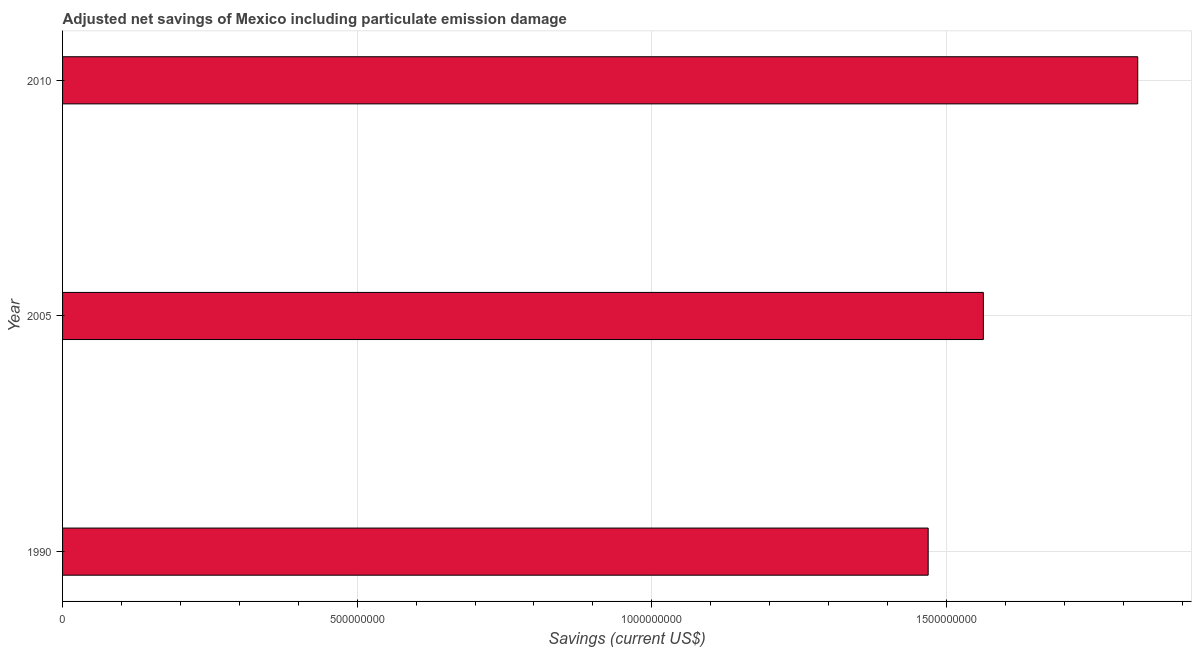Does the graph contain any zero values?
Give a very brief answer. No. Does the graph contain grids?
Ensure brevity in your answer.  Yes. What is the title of the graph?
Keep it short and to the point. Adjusted net savings of Mexico including particulate emission damage. What is the label or title of the X-axis?
Provide a succinct answer. Savings (current US$). What is the adjusted net savings in 2005?
Your response must be concise. 1.56e+09. Across all years, what is the maximum adjusted net savings?
Your answer should be very brief. 1.82e+09. Across all years, what is the minimum adjusted net savings?
Provide a short and direct response. 1.47e+09. What is the sum of the adjusted net savings?
Keep it short and to the point. 4.86e+09. What is the difference between the adjusted net savings in 1990 and 2010?
Provide a short and direct response. -3.56e+08. What is the average adjusted net savings per year?
Give a very brief answer. 1.62e+09. What is the median adjusted net savings?
Offer a very short reply. 1.56e+09. In how many years, is the adjusted net savings greater than 500000000 US$?
Make the answer very short. 3. Do a majority of the years between 1990 and 2005 (inclusive) have adjusted net savings greater than 1500000000 US$?
Make the answer very short. No. What is the ratio of the adjusted net savings in 1990 to that in 2010?
Your answer should be very brief. 0.81. Is the adjusted net savings in 1990 less than that in 2010?
Provide a succinct answer. Yes. Is the difference between the adjusted net savings in 1990 and 2010 greater than the difference between any two years?
Make the answer very short. Yes. What is the difference between the highest and the second highest adjusted net savings?
Your answer should be very brief. 2.62e+08. Is the sum of the adjusted net savings in 2005 and 2010 greater than the maximum adjusted net savings across all years?
Ensure brevity in your answer.  Yes. What is the difference between the highest and the lowest adjusted net savings?
Offer a terse response. 3.56e+08. Are all the bars in the graph horizontal?
Provide a succinct answer. Yes. How many years are there in the graph?
Give a very brief answer. 3. What is the difference between two consecutive major ticks on the X-axis?
Provide a succinct answer. 5.00e+08. What is the Savings (current US$) of 1990?
Your answer should be compact. 1.47e+09. What is the Savings (current US$) of 2005?
Make the answer very short. 1.56e+09. What is the Savings (current US$) in 2010?
Give a very brief answer. 1.82e+09. What is the difference between the Savings (current US$) in 1990 and 2005?
Make the answer very short. -9.37e+07. What is the difference between the Savings (current US$) in 1990 and 2010?
Your answer should be very brief. -3.56e+08. What is the difference between the Savings (current US$) in 2005 and 2010?
Ensure brevity in your answer.  -2.62e+08. What is the ratio of the Savings (current US$) in 1990 to that in 2005?
Keep it short and to the point. 0.94. What is the ratio of the Savings (current US$) in 1990 to that in 2010?
Your response must be concise. 0.81. What is the ratio of the Savings (current US$) in 2005 to that in 2010?
Provide a short and direct response. 0.86. 